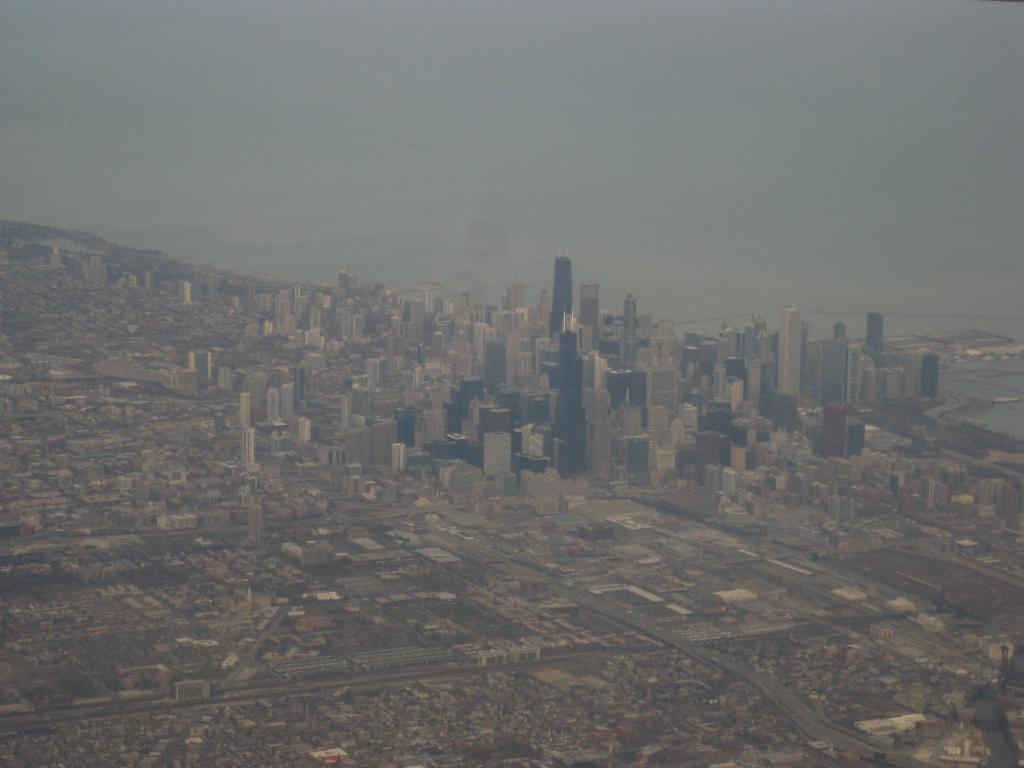What type of structures can be seen in the image? There are buildings in the image. What is visible at the top of the image? The sky is visible at the top of the image. What type of rock can be seen in the image? There is no rock present in the image; it features buildings and the sky. What type of gold object is visible in the image? There is no gold object present in the image. 